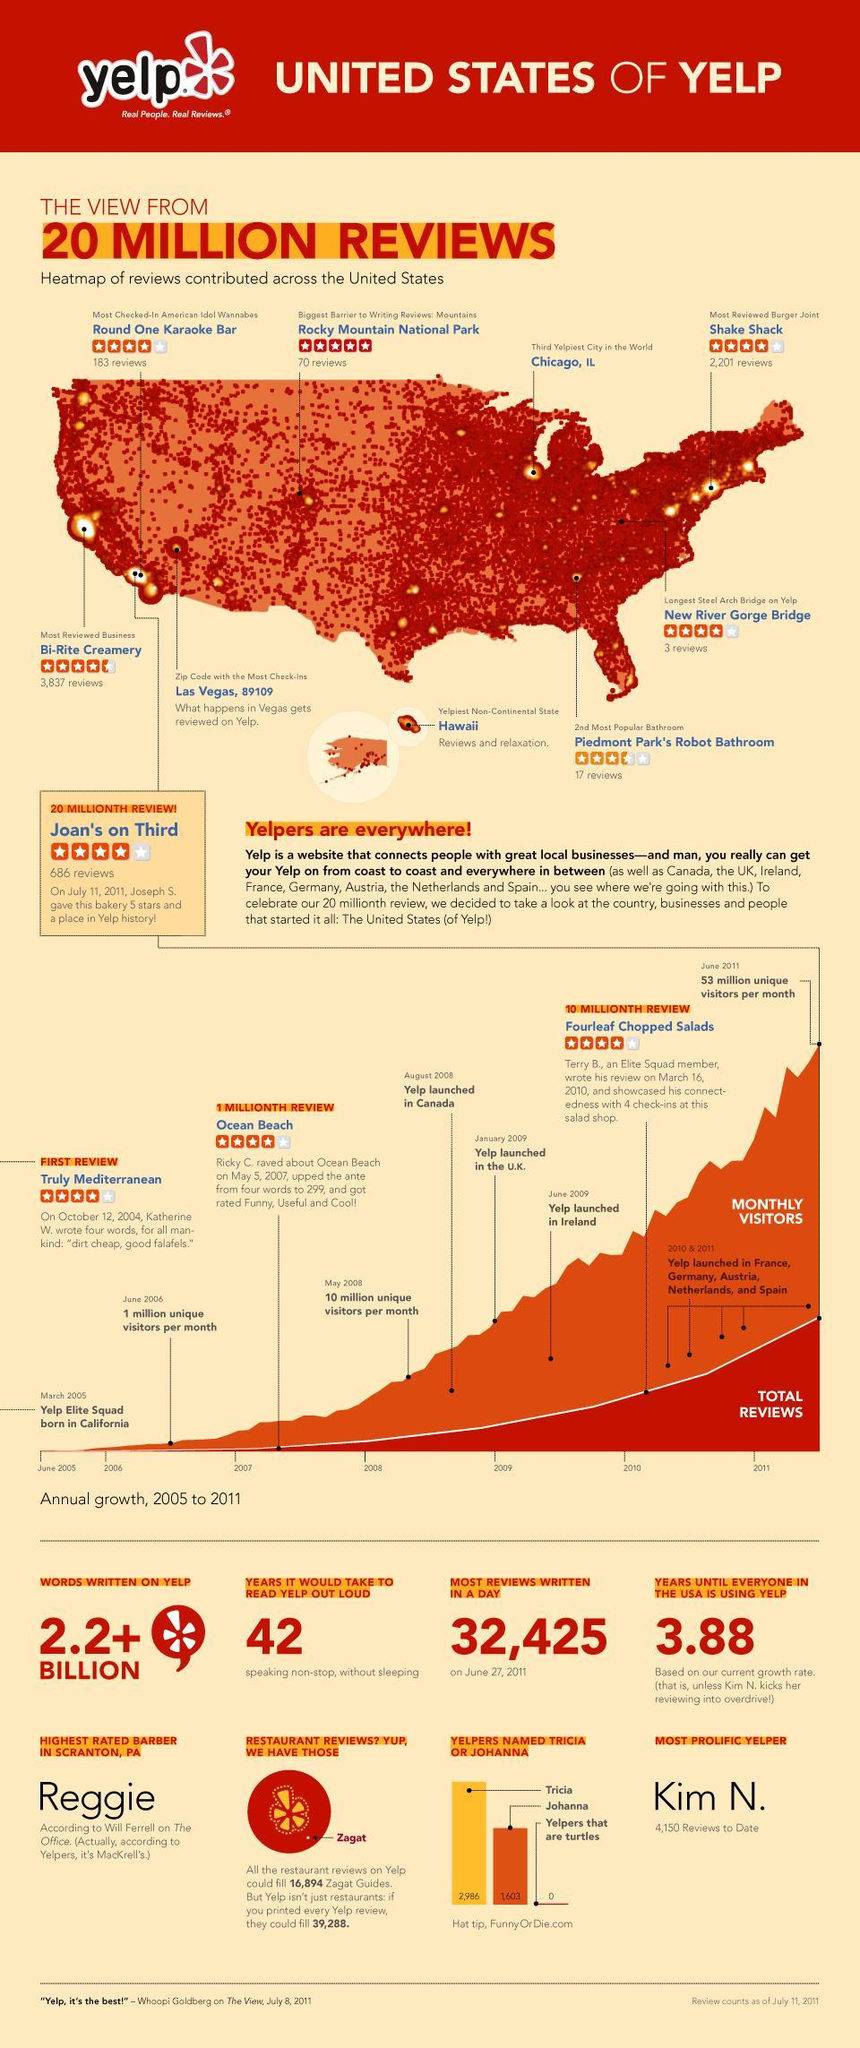When was Yelp launched in Canada?
Answer the question with a short phrase. August 2008 When was Yelp launched in U.K? January 2009 What is the highest no of reviews written in a day on yelp? 32,425 Who is the most prolific yelper with 4,150 reviews to date? Kim N. Which is the third yelpiest city in the world? Chicago, IL What is the zip code in U.S. that has seen most no of check-ins on Yelp? 89109 How many reviews are available for 'Shake Shack' Burger joint on Yelp? 2,201 reviews When did yelp attained 53 million unique visitors per month? June 2011 Which is the most reviewed Burger joint in U.S on Yelp? Shake Shack Which is the most reviewed business in United States on Yelp? Bi-Rite Creamery 